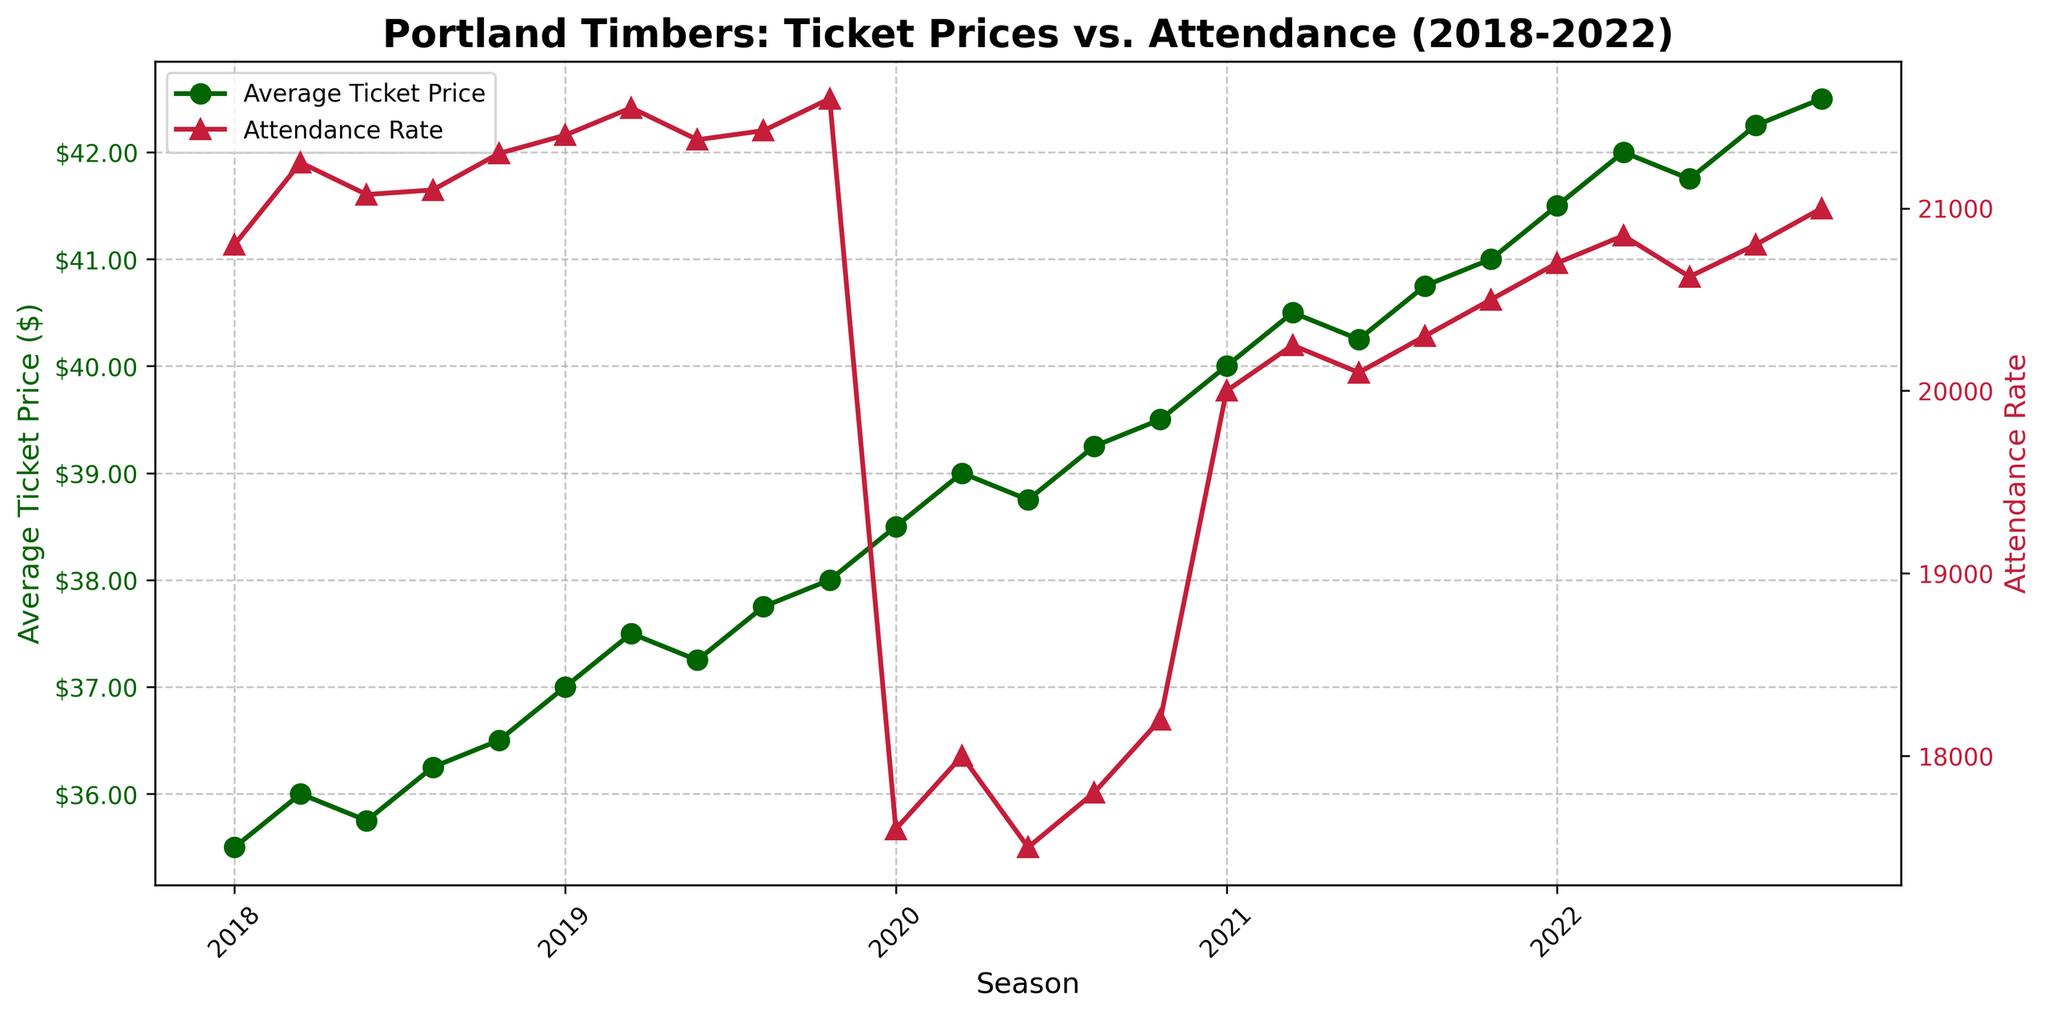What are the lowest and highest average ticket prices displayed in the figure? To find these values, look at the y-axis for "Average Ticket Price ($)" and observe the data points. The lowest point is $35.50, and the highest point is $42.50.
Answer: $35.50, $42.50 What is the average attendance rate for the 2019 season? Find the data points for 2019 on the x-axis and check the corresponding attendance rates. Sum these values: 21400 + 21550 + 21375 + 21425 + 21600 = 107350. Divide by 5 to get the average: 107350/5 = 21470.
Answer: 21470 How does the attendance rate in 2020 compare to 2019? 2020 shows lower attendance rates than 2019. Check the y-axis for the "Attendance Rate" and observe that all 2020 data points are significantly below the 2019 data points.
Answer: Lower What is the difference in average ticket price between the first data point in 2018 and the last data point in 2022? The first data point in 2018 is $35.50, and the last in 2022 is $42.50. Calculate the difference: $42.50 - $35.50 = $7.00.
Answer: $7.00 Which season had the highest average ticket price? Look at the peak values on the y-axis for "Average Ticket Price ($)" for each season. The highest ticket price ($42.50) is in the 2022 season.
Answer: 2022 What trend can be observed in the ticket prices from 2018 to 2022? Observe the y-axis for "Average Ticket Price ($)" over the seasons. There is a clear upward trend in average ticket prices from 2018 to 2022.
Answer: Upward trend Which two consecutive seasons have the largest difference in average attendance rates? Compare the average attendance rates for each season. The largest drop happens between 2019 and 2020 (from high attendance rates in 2019 to lower rates in 2020).
Answer: 2019 to 2020 By how much did the average ticket price increase from 2018 to 2019? The average ticket price in 2018 starts at around $35.50 and ends at $36.50. In 2019, it starts at $37.00 and ends at $38.00. Comparing the endpoint of 2018 ($36.50) and start of 2019 ($37.00), the increase is $0.50.
Answer: $0.50 How did the attendance rate change during the 2020 season? Review the attendance rates along the x-axis for 2020. The attendance started at 17600, increased slightly, but stayed relatively low compared to other seasons, with the highest point at 18200. Overall, low and stable changes.
Answer: Low and stable 